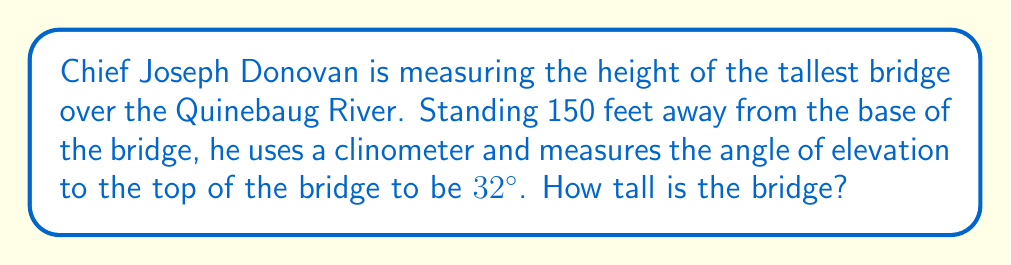Could you help me with this problem? Let's approach this step-by-step using trigonometric ratios:

1) First, let's visualize the problem:

[asy]
import geometry;

size(200);
pair A = (0,0), B = (150,0), C = (0,96);
draw(A--B--C--A);
label("150 ft", (75,0), S);
label("Bridge", (0,48), W);
label("32°", (15,0), NE);
label("x", (0,48), E);
draw(rightanglemark(A,B,C,20));
[/asy]

2) We have a right triangle where:
   - The adjacent side is 150 feet (distance from Chief Donovan to the bridge)
   - The angle of elevation is 32°
   - We need to find the opposite side (height of the bridge)

3) In this scenario, we can use the tangent ratio:

   $$\tan \theta = \frac{\text{opposite}}{\text{adjacent}}$$

4) Plugging in our known values:

   $$\tan 32° = \frac{x}{150}$$

   Where $x$ is the height of the bridge.

5) To solve for $x$, we multiply both sides by 150:

   $$150 \cdot \tan 32° = x$$

6) Using a calculator (or trig table):

   $$x = 150 \cdot 0.6249 = 93.735 \text{ feet}$$

7) Rounding to the nearest foot:

   $$x \approx 94 \text{ feet}$$
Answer: The tallest bridge over the Quinebaug River is approximately 94 feet tall. 